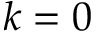Convert formula to latex. <formula><loc_0><loc_0><loc_500><loc_500>k = 0</formula> 